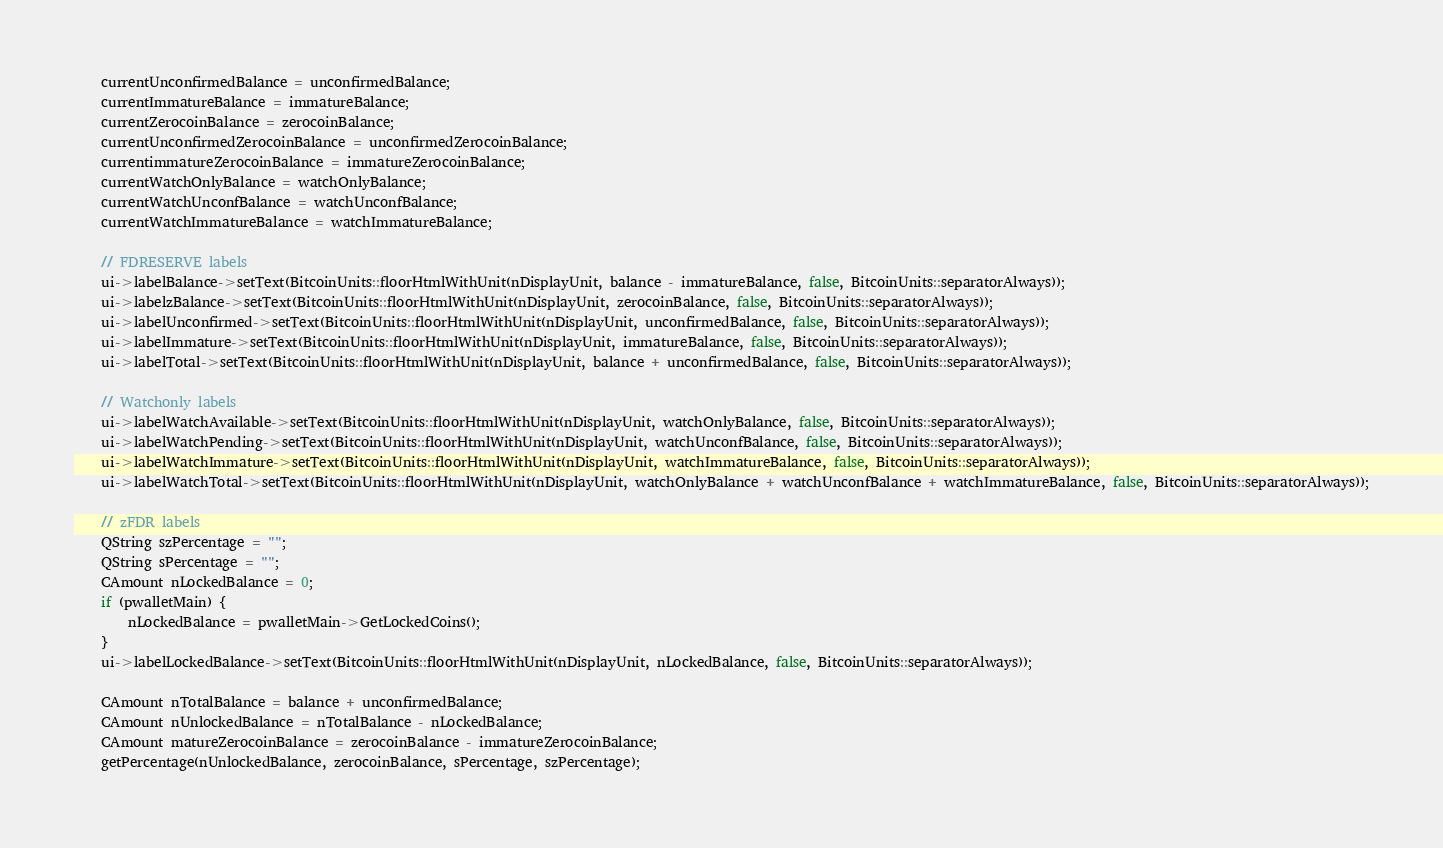Convert code to text. <code><loc_0><loc_0><loc_500><loc_500><_C++_>    currentUnconfirmedBalance = unconfirmedBalance;
    currentImmatureBalance = immatureBalance;
    currentZerocoinBalance = zerocoinBalance;
    currentUnconfirmedZerocoinBalance = unconfirmedZerocoinBalance;
    currentimmatureZerocoinBalance = immatureZerocoinBalance;
    currentWatchOnlyBalance = watchOnlyBalance;
    currentWatchUnconfBalance = watchUnconfBalance;
    currentWatchImmatureBalance = watchImmatureBalance;

    // FDRESERVE labels
    ui->labelBalance->setText(BitcoinUnits::floorHtmlWithUnit(nDisplayUnit, balance - immatureBalance, false, BitcoinUnits::separatorAlways));
    ui->labelzBalance->setText(BitcoinUnits::floorHtmlWithUnit(nDisplayUnit, zerocoinBalance, false, BitcoinUnits::separatorAlways));
    ui->labelUnconfirmed->setText(BitcoinUnits::floorHtmlWithUnit(nDisplayUnit, unconfirmedBalance, false, BitcoinUnits::separatorAlways));
    ui->labelImmature->setText(BitcoinUnits::floorHtmlWithUnit(nDisplayUnit, immatureBalance, false, BitcoinUnits::separatorAlways));
    ui->labelTotal->setText(BitcoinUnits::floorHtmlWithUnit(nDisplayUnit, balance + unconfirmedBalance, false, BitcoinUnits::separatorAlways));

    // Watchonly labels
    ui->labelWatchAvailable->setText(BitcoinUnits::floorHtmlWithUnit(nDisplayUnit, watchOnlyBalance, false, BitcoinUnits::separatorAlways));
    ui->labelWatchPending->setText(BitcoinUnits::floorHtmlWithUnit(nDisplayUnit, watchUnconfBalance, false, BitcoinUnits::separatorAlways));
    ui->labelWatchImmature->setText(BitcoinUnits::floorHtmlWithUnit(nDisplayUnit, watchImmatureBalance, false, BitcoinUnits::separatorAlways));
    ui->labelWatchTotal->setText(BitcoinUnits::floorHtmlWithUnit(nDisplayUnit, watchOnlyBalance + watchUnconfBalance + watchImmatureBalance, false, BitcoinUnits::separatorAlways));

    // zFDR labels
    QString szPercentage = "";
    QString sPercentage = "";
    CAmount nLockedBalance = 0;
    if (pwalletMain) {
        nLockedBalance = pwalletMain->GetLockedCoins();
    }
    ui->labelLockedBalance->setText(BitcoinUnits::floorHtmlWithUnit(nDisplayUnit, nLockedBalance, false, BitcoinUnits::separatorAlways));

    CAmount nTotalBalance = balance + unconfirmedBalance;
    CAmount nUnlockedBalance = nTotalBalance - nLockedBalance;
    CAmount matureZerocoinBalance = zerocoinBalance - immatureZerocoinBalance;
    getPercentage(nUnlockedBalance, zerocoinBalance, sPercentage, szPercentage);
</code> 